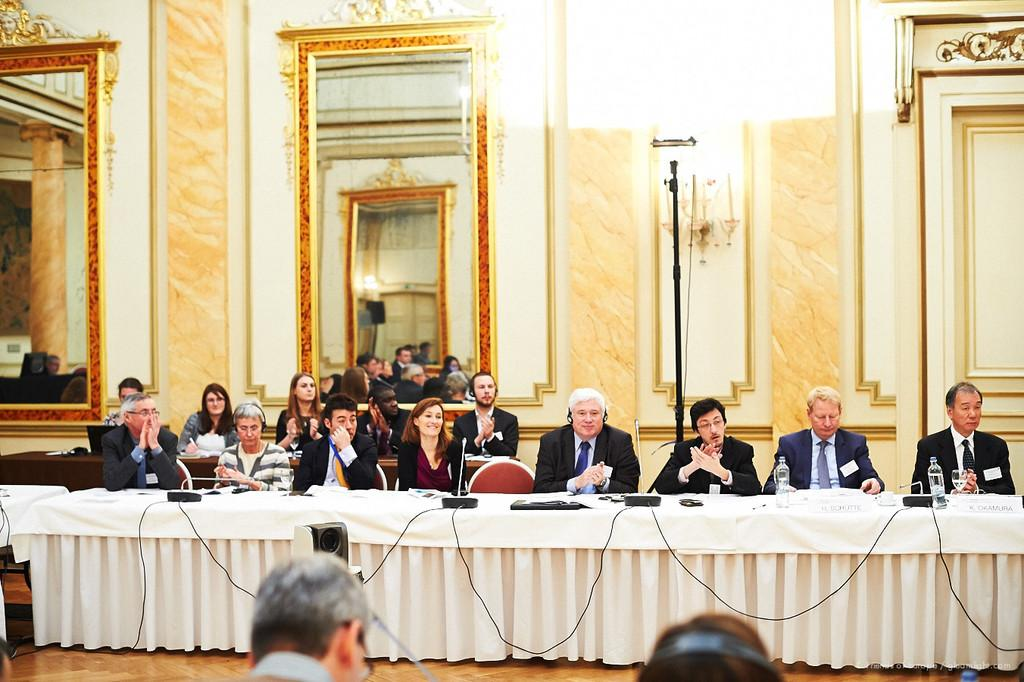What are the people in the image doing? The people in the image are sitting. What is present on which the people are sitting? There is a table in the image. What is covering the table? There is a white cloth on the table. What color is the wall in the image? The wall in the image is yellow. What object in the image allows for reflection? There is a mirror in the image. What type of pie is being served on the sidewalk in the image? There is no pie or sidewalk present in the image. 